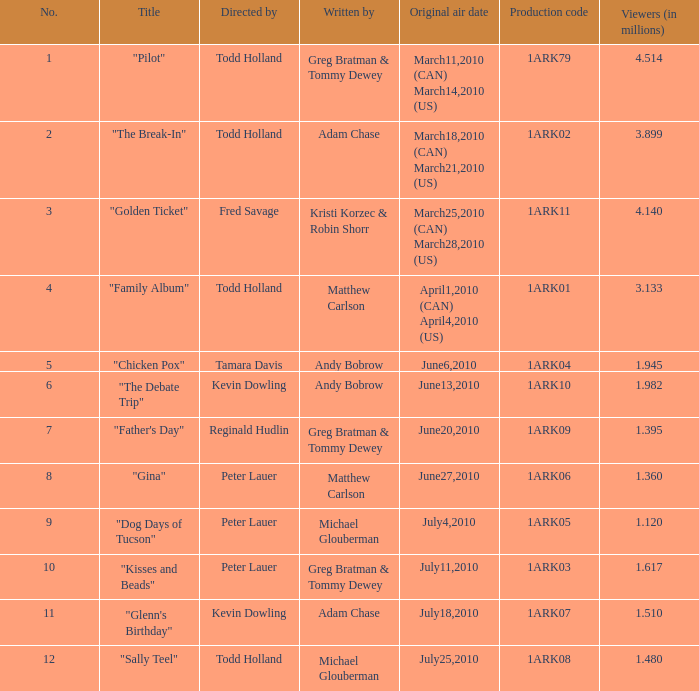Provide a list of individuals who wrote for the production code 1ark07. Adam Chase. 